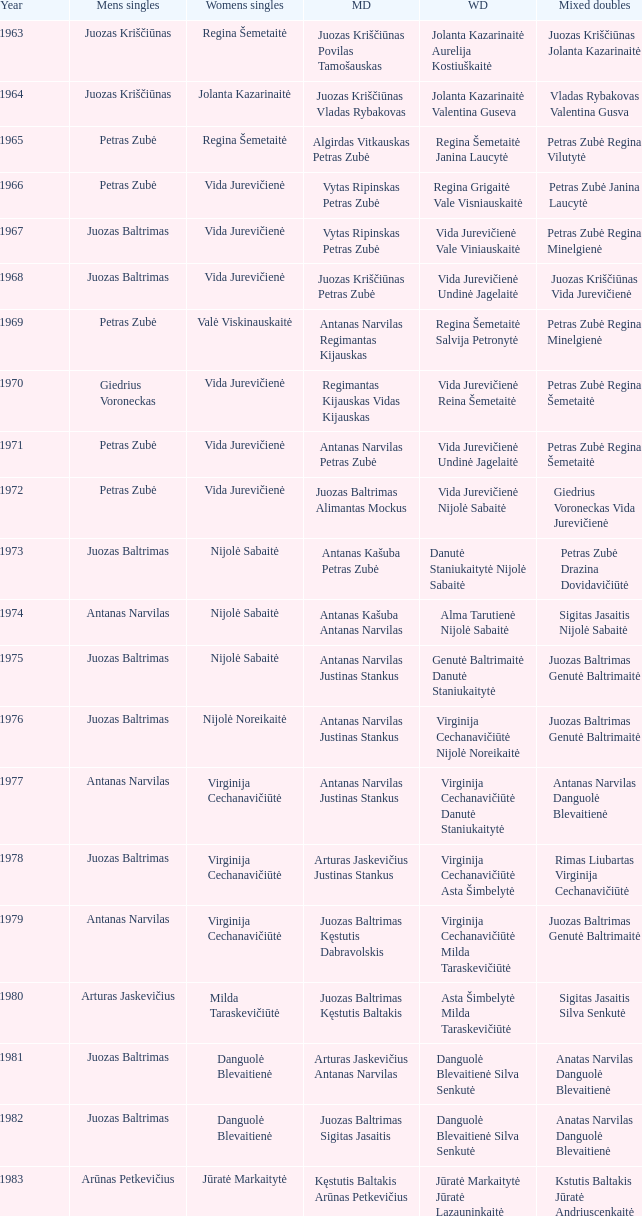How many years did aivaras kvedarauskas juozas spelveris participate in the men's doubles? 1.0. 